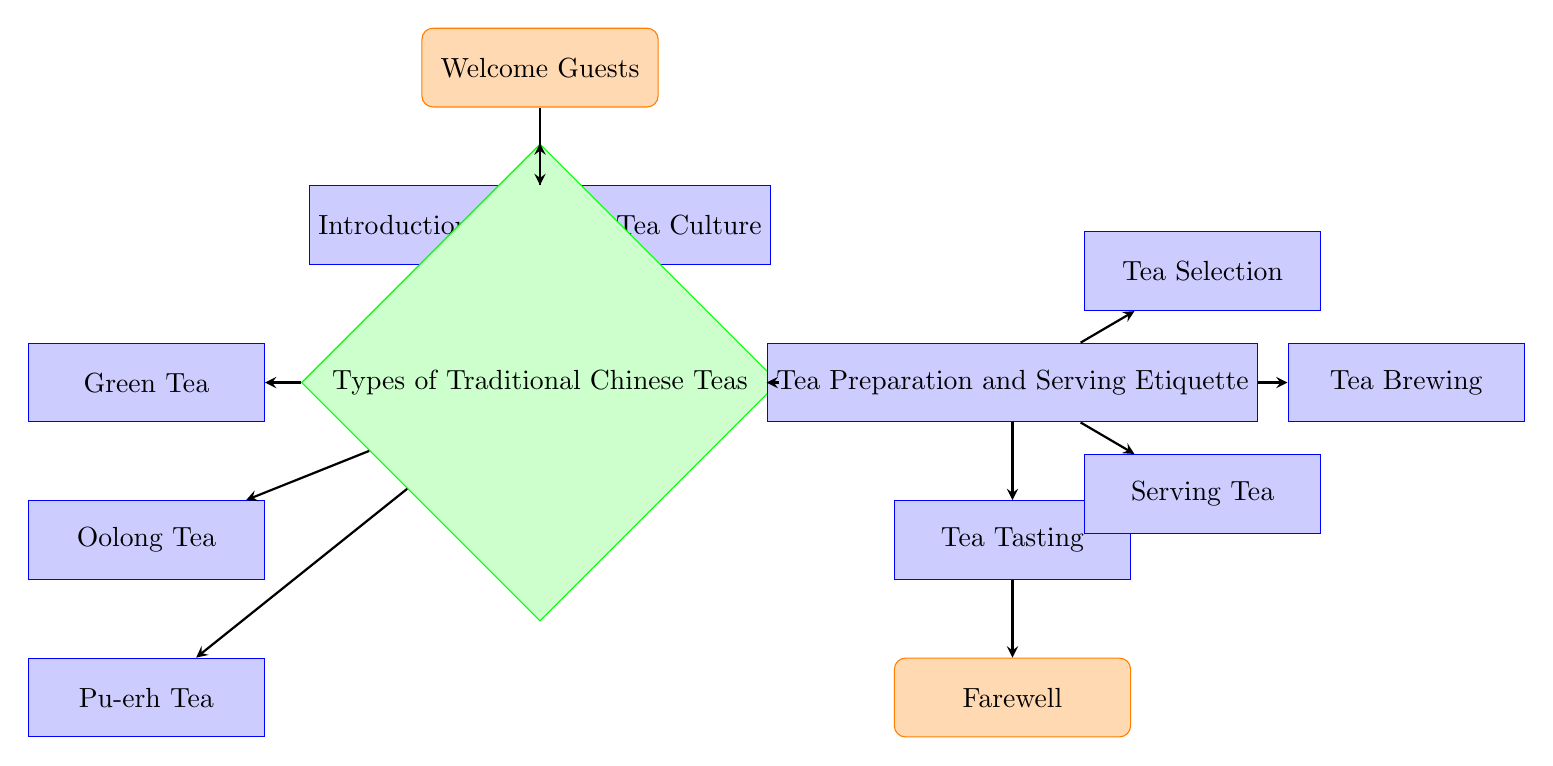What is the first step in the flow chart? The first node in the flow chart is "Welcome Guests," which serves as the starting point of the process.
Answer: Welcome Guests How many types of traditional Chinese teas are introduced? The decision node "Types of Traditional Chinese Teas" leads to three branches: Green Tea, Oolong Tea, and Pu-erh Tea. Therefore, there are three types introduced.
Answer: Three What comes after "Introduction to Chinese Tea Culture"? Following "Introduction to Chinese Tea Culture," the next node in the flow chart is "Types of Traditional Chinese Teas." This is determined by tracing the arrow from the introduction node to the next.
Answer: Types of Traditional Chinese Teas What are the components of "Tea Preparation and Serving Etiquette"? The "Tea Preparation and Serving Etiquette" node expands into three components: Tea Selection, Tea Brewing, and Serving Tea, which can be identified by following the arrows from the prep node.
Answer: Tea Selection, Tea Brewing, Serving Tea Which tea is considered light and fresh? The node labeled "Green Tea" directly states that it is light and fresh, allowing for a direct identification based on the description provided in the diagram.
Answer: Green Tea What is the final step in the flow chart? The flow chart ends with the node "Farewell," which is the last process indicated after "Tea Tasting," following the directed flow of the diagram.
Answer: Farewell What is the relationship between "Tea Brewing" and "Tea Selection"? Both "Tea Brewing" and "Tea Selection" are components underneath the "Tea Preparation and Serving Etiquette" node, showing a parallel relationship in the overall tea preparation process.
Answer: Parallel relationship How many nodes lead to the "Tea Tasting" node? There is one node that leads directly to "Tea Tasting," which is "Tea Preparation and Serving Etiquette." Tracing the arrows reveals this singular pathway towards tasting the tea.
Answer: One 